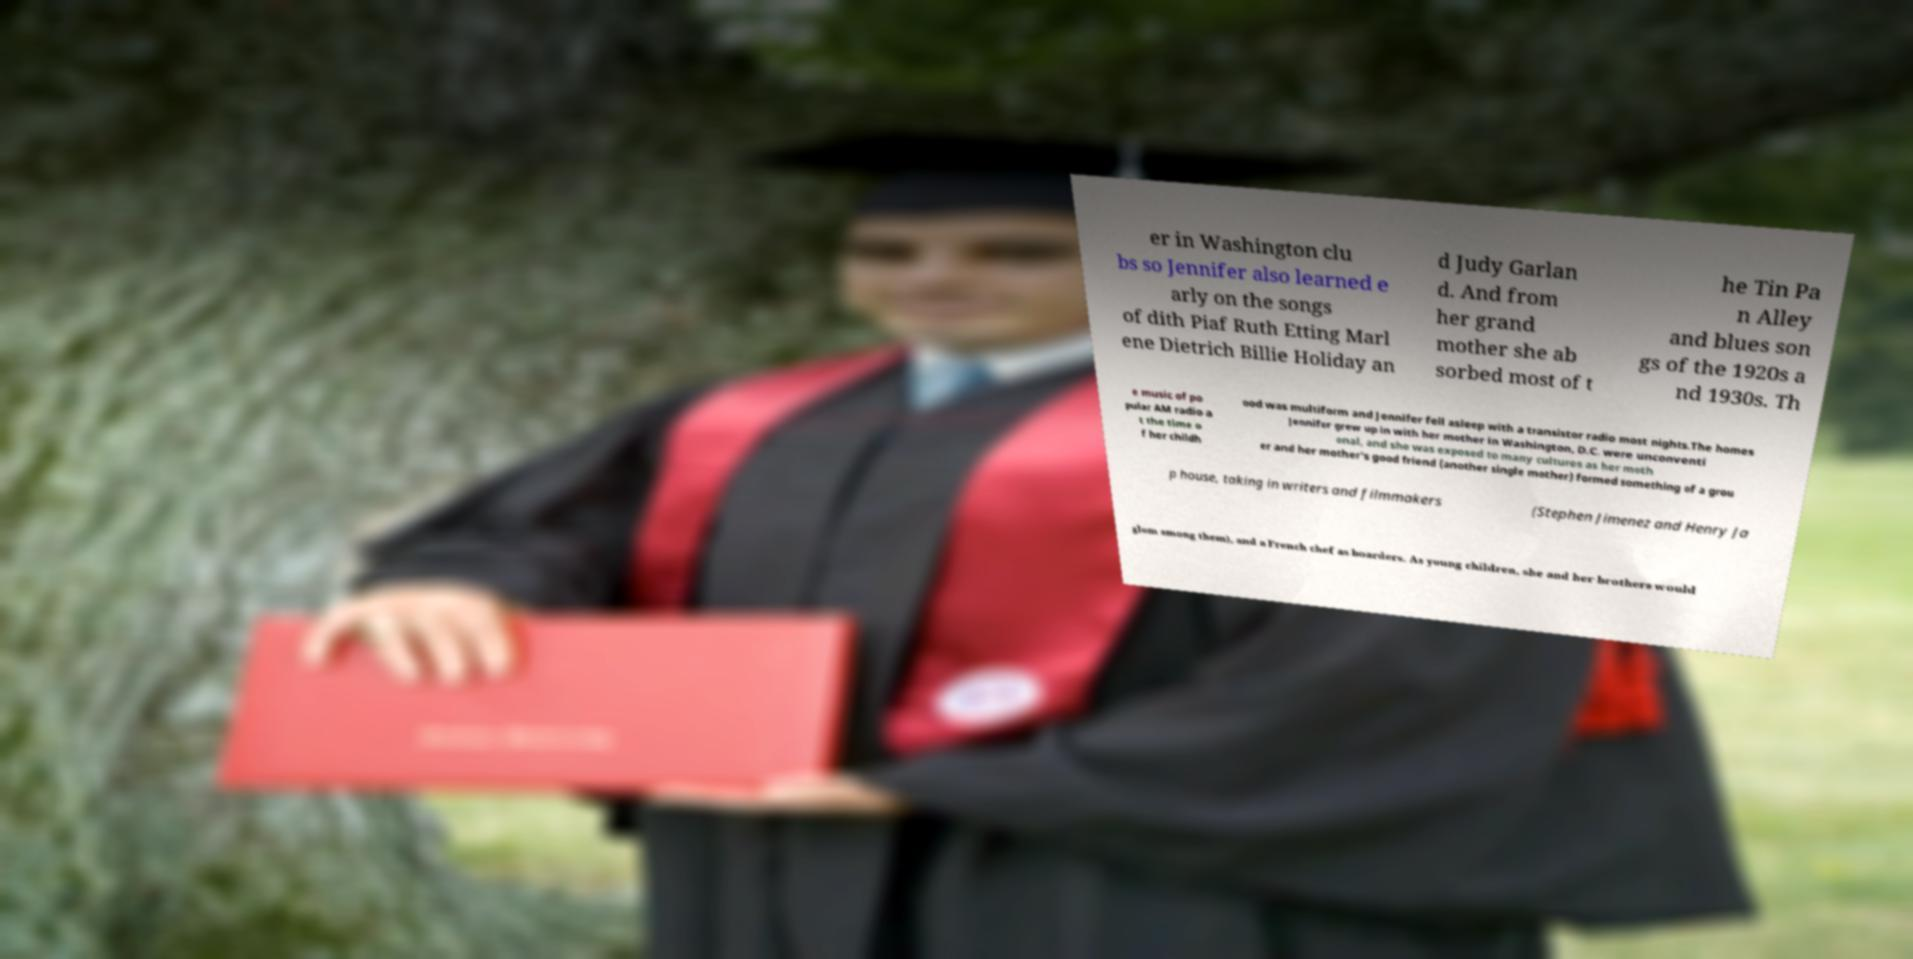What messages or text are displayed in this image? I need them in a readable, typed format. er in Washington clu bs so Jennifer also learned e arly on the songs of dith Piaf Ruth Etting Marl ene Dietrich Billie Holiday an d Judy Garlan d. And from her grand mother she ab sorbed most of t he Tin Pa n Alley and blues son gs of the 1920s a nd 1930s. Th e music of po pular AM radio a t the time o f her childh ood was multiform and Jennifer fell asleep with a transistor radio most nights.The homes Jennifer grew up in with her mother in Washington, D.C. were unconventi onal, and she was exposed to many cultures as her moth er and her mother's good friend (another single mother) formed something of a grou p house, taking in writers and filmmakers (Stephen Jimenez and Henry Ja glom among them), and a French chef as boarders. As young children, she and her brothers would 